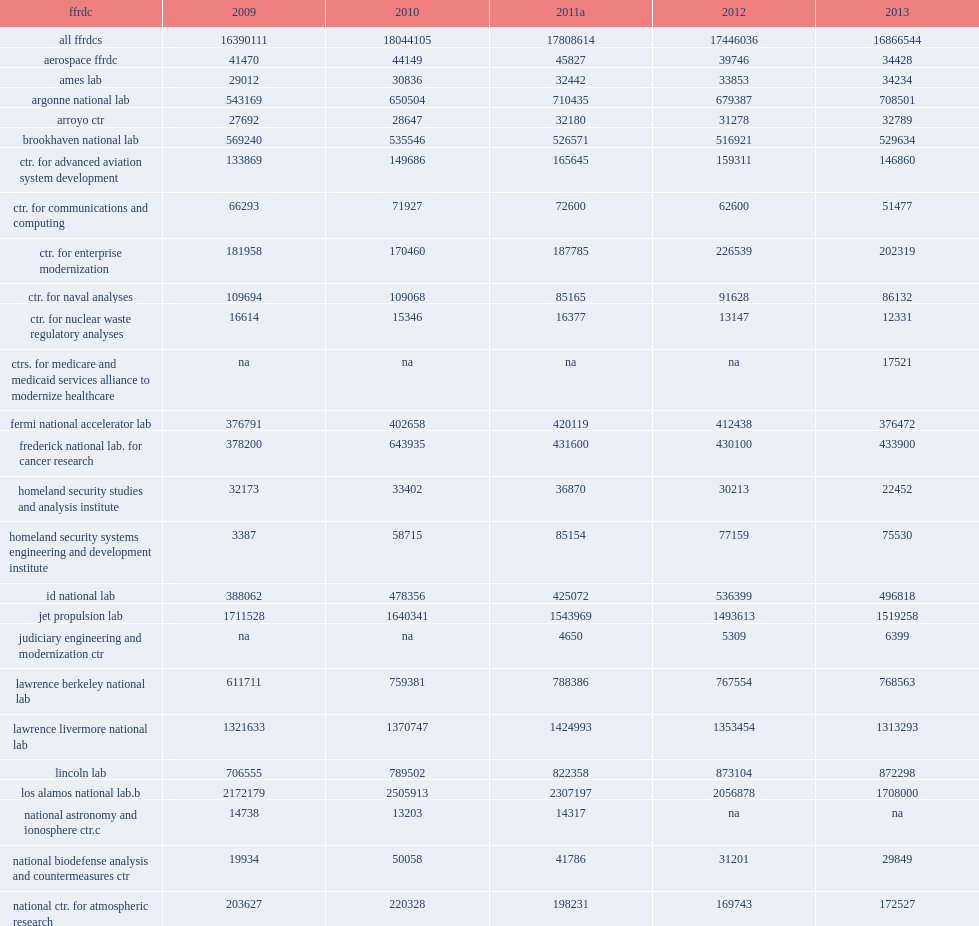How many thousand dollars did the nation's 40 federally funded r&d centers (ffrdcs) spend on research and development in fy 2013? 16866544.0. 